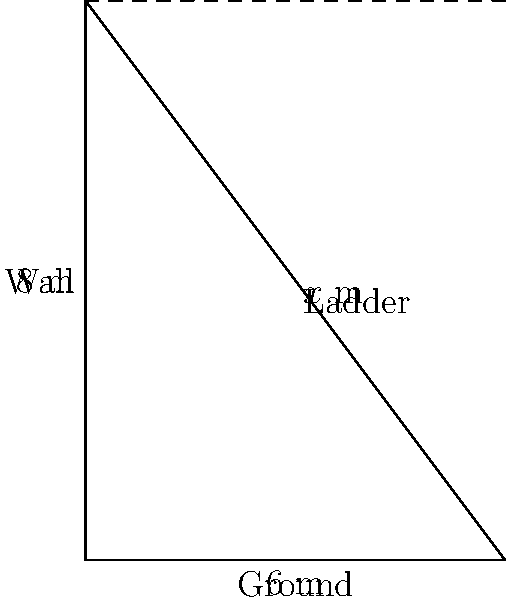A ladder is leaning against a wall, forming a right triangle with the ground and the wall. The ladder reaches a height of 8 meters on the wall, and its base is 6 meters away from the wall. Using the Pythagorean theorem, calculate the length of the ladder to the nearest tenth of a meter. Let's approach this step-by-step:

1) We can represent this situation as a right triangle where:
   - The wall forms the height (8 meters)
   - The ground distance forms the base (6 meters)
   - The ladder forms the hypotenuse (length unknown, let's call it $x$)

2) The Pythagorean theorem states that in a right triangle:
   $a^2 + b^2 = c^2$
   where $c$ is the hypotenuse and $a$ and $b$ are the other two sides.

3) Let's plug in our known values:
   $8^2 + 6^2 = x^2$

4) Simplify:
   $64 + 36 = x^2$
   $100 = x^2$

5) To find $x$, we need to take the square root of both sides:
   $\sqrt{100} = x$

6) Simplify:
   $x = 10$

7) The question asks for the answer to the nearest tenth of a meter, but 10 is already a whole number, so no rounding is necessary.
Answer: 10 m 